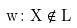<formula> <loc_0><loc_0><loc_500><loc_500>w \colon X \notin L</formula> 